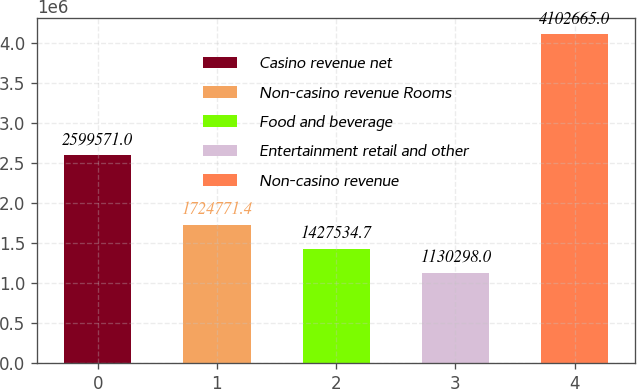Convert chart. <chart><loc_0><loc_0><loc_500><loc_500><bar_chart><fcel>Casino revenue net<fcel>Non-casino revenue Rooms<fcel>Food and beverage<fcel>Entertainment retail and other<fcel>Non-casino revenue<nl><fcel>2.59957e+06<fcel>1.72477e+06<fcel>1.42753e+06<fcel>1.1303e+06<fcel>4.10266e+06<nl></chart> 